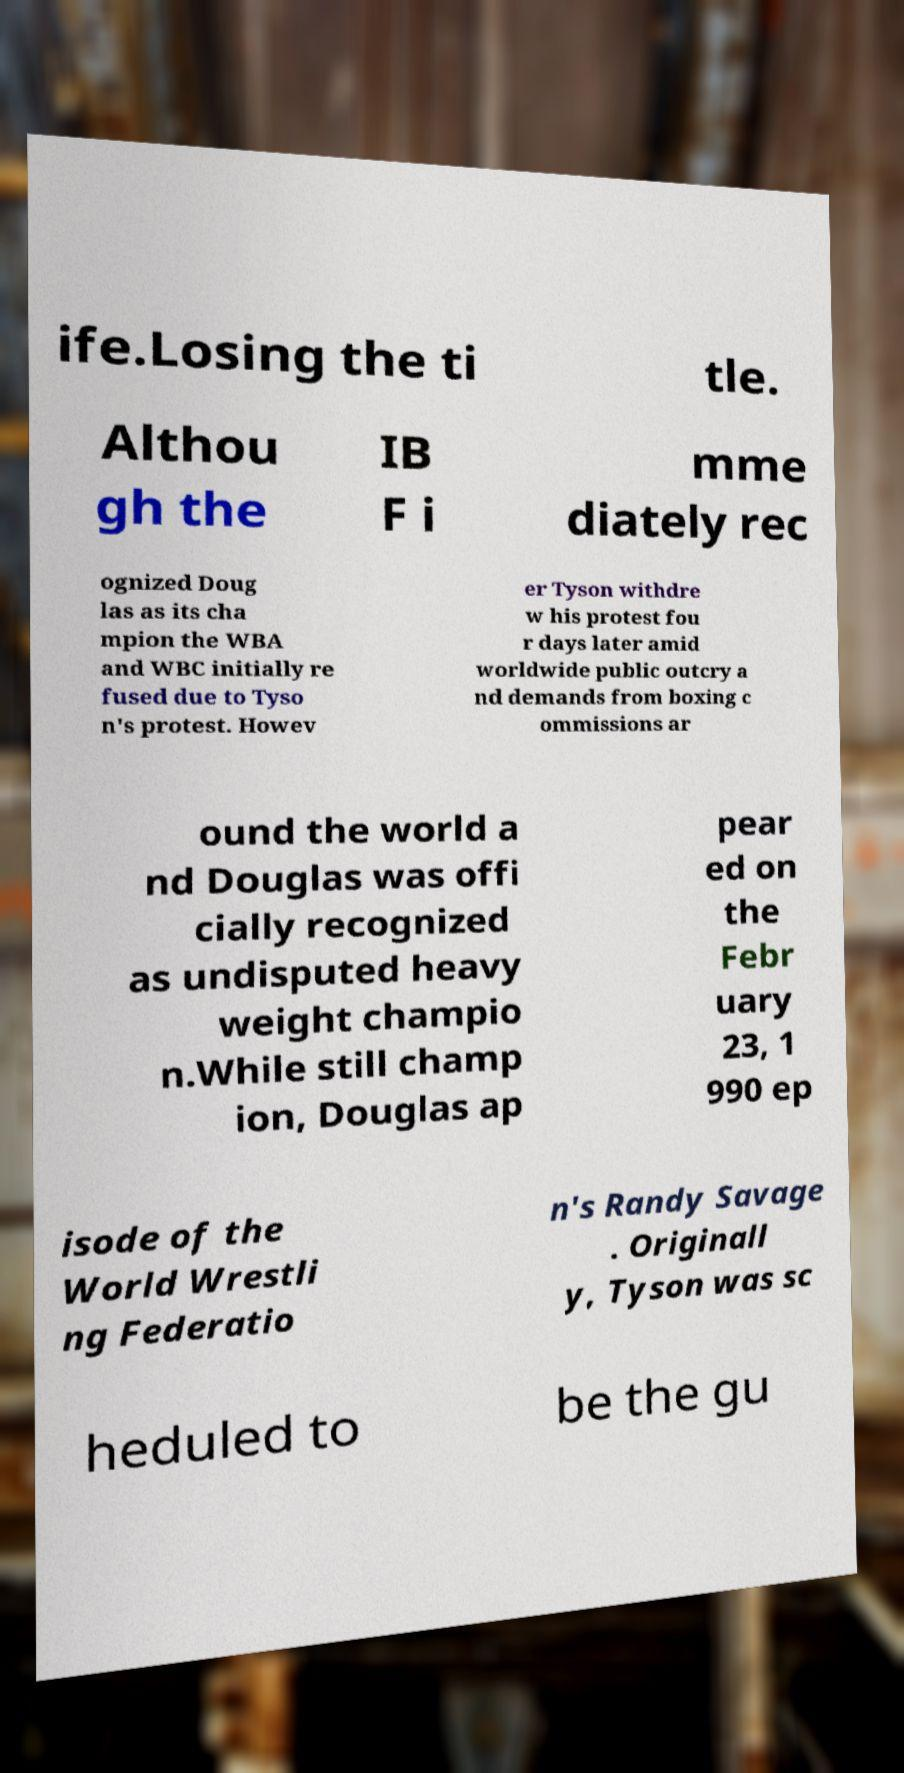Please read and relay the text visible in this image. What does it say? ife.Losing the ti tle. Althou gh the IB F i mme diately rec ognized Doug las as its cha mpion the WBA and WBC initially re fused due to Tyso n's protest. Howev er Tyson withdre w his protest fou r days later amid worldwide public outcry a nd demands from boxing c ommissions ar ound the world a nd Douglas was offi cially recognized as undisputed heavy weight champio n.While still champ ion, Douglas ap pear ed on the Febr uary 23, 1 990 ep isode of the World Wrestli ng Federatio n's Randy Savage . Originall y, Tyson was sc heduled to be the gu 